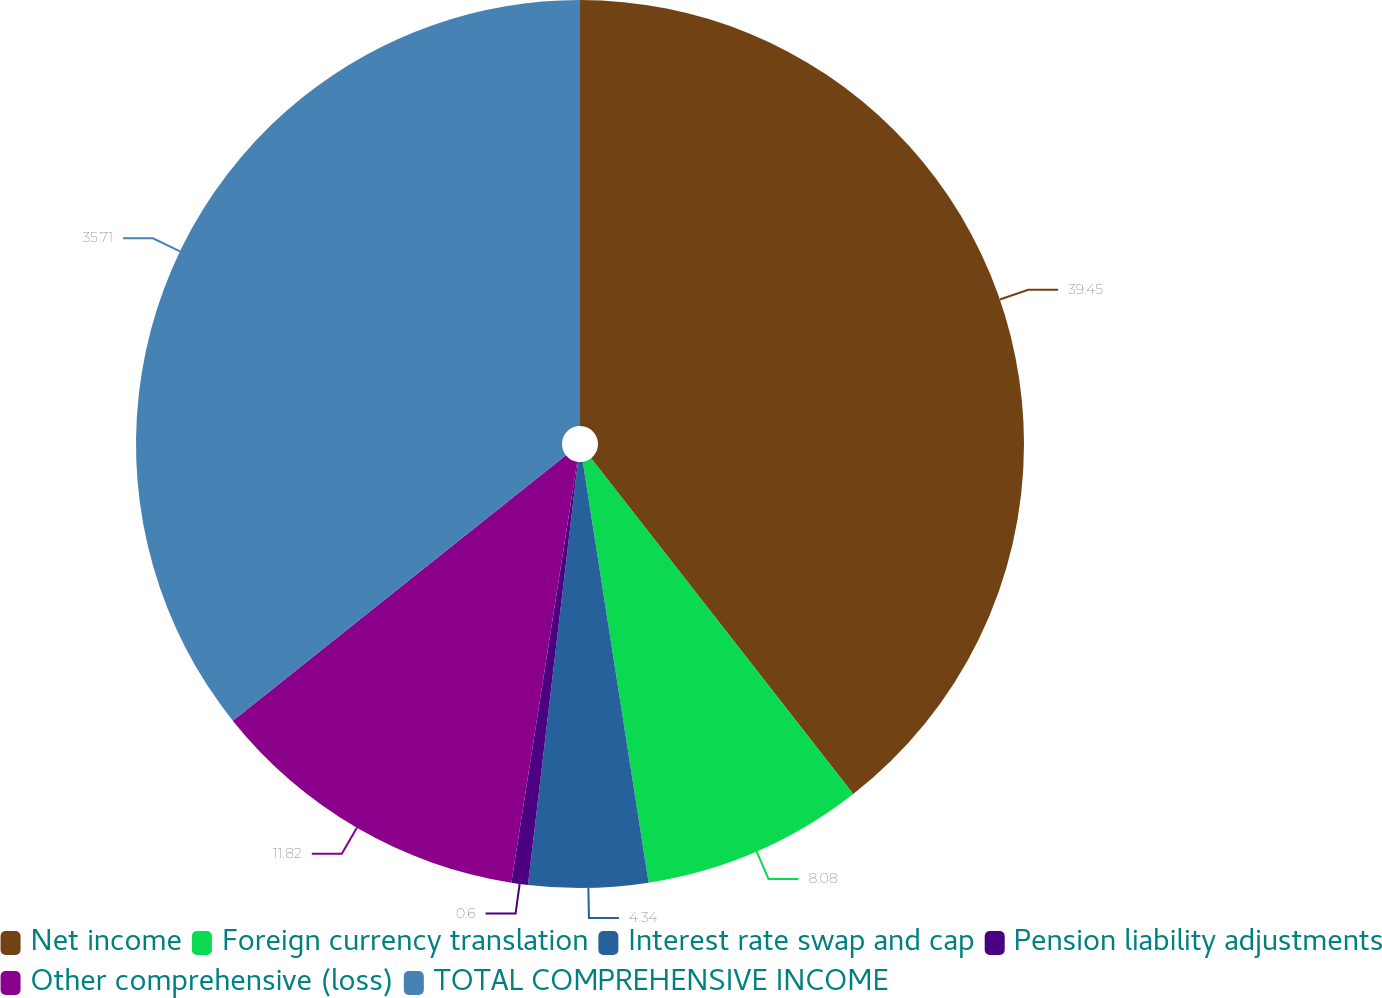Convert chart to OTSL. <chart><loc_0><loc_0><loc_500><loc_500><pie_chart><fcel>Net income<fcel>Foreign currency translation<fcel>Interest rate swap and cap<fcel>Pension liability adjustments<fcel>Other comprehensive (loss)<fcel>TOTAL COMPREHENSIVE INCOME<nl><fcel>39.45%<fcel>8.08%<fcel>4.34%<fcel>0.6%<fcel>11.82%<fcel>35.71%<nl></chart> 